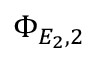<formula> <loc_0><loc_0><loc_500><loc_500>\Phi _ { E _ { 2 } , 2 }</formula> 